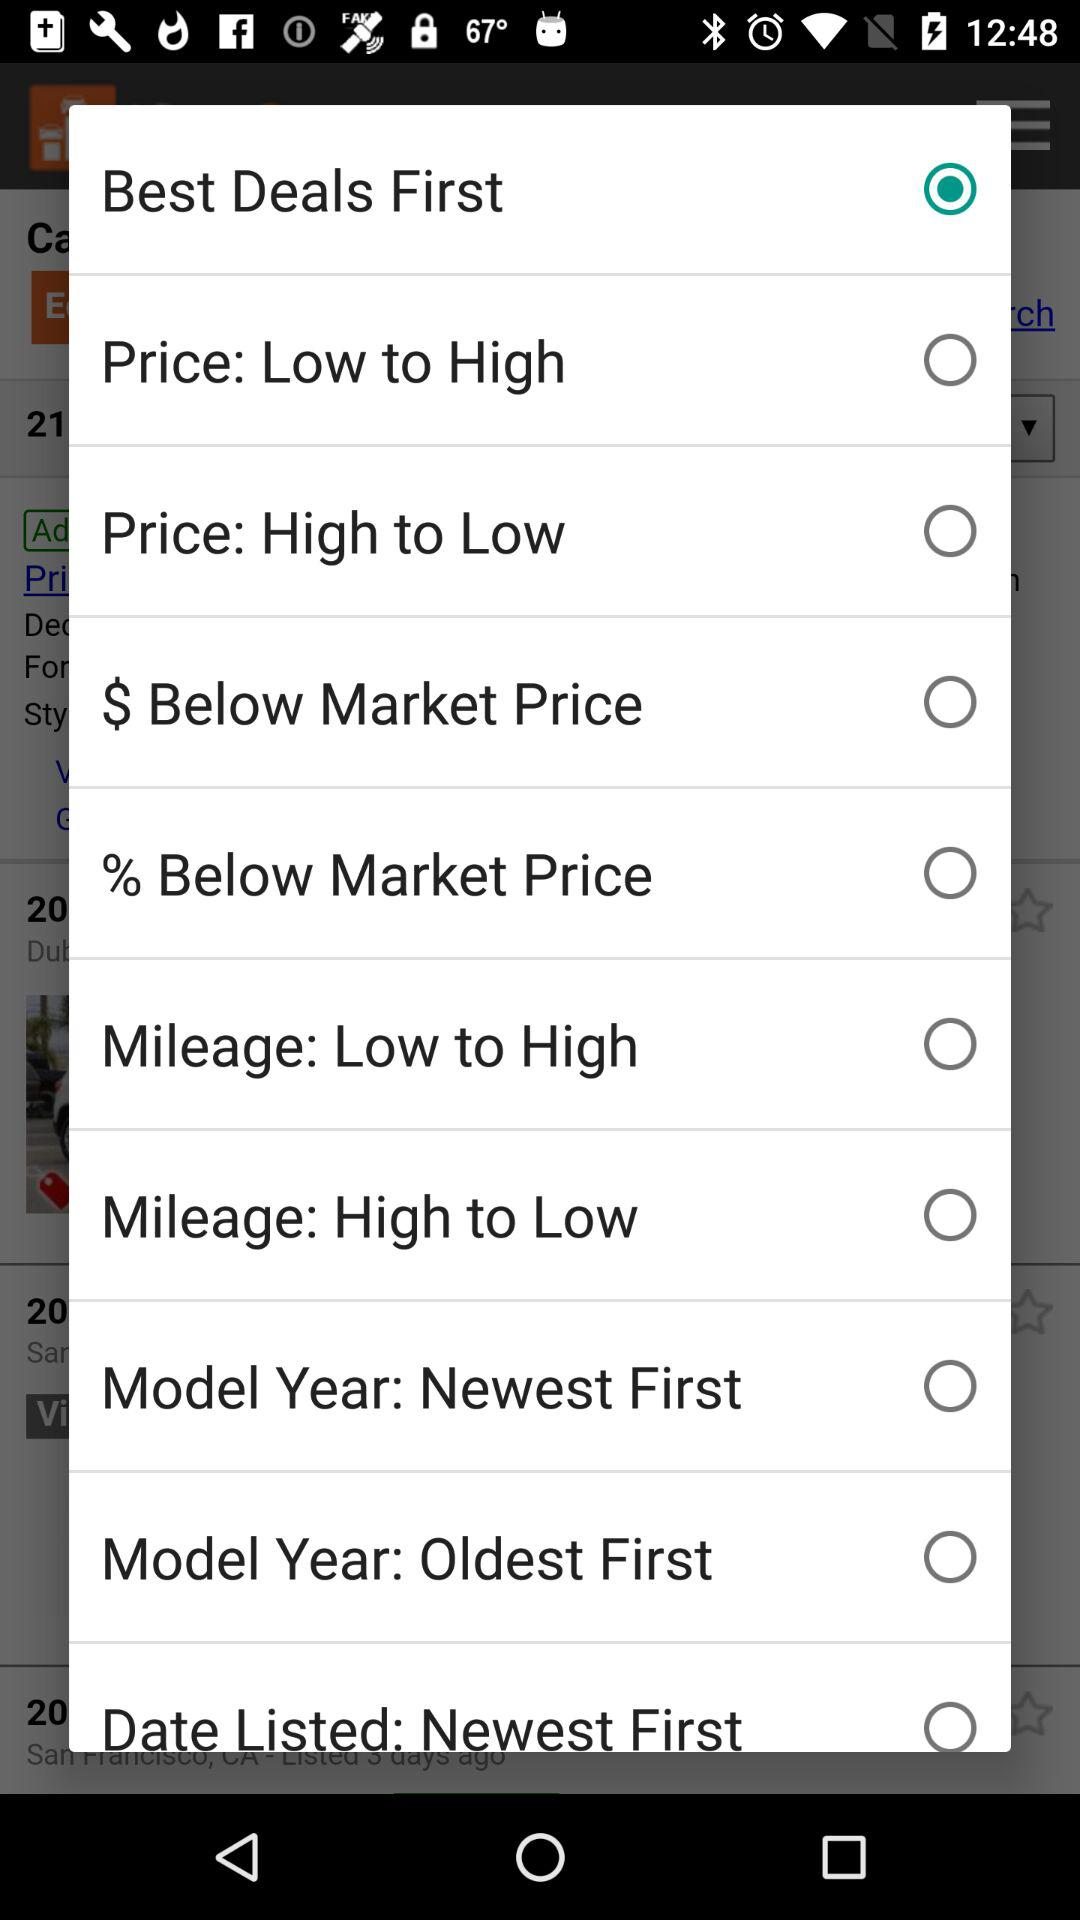Which option has been selected? The option that has been selected is "Best Deals First". 